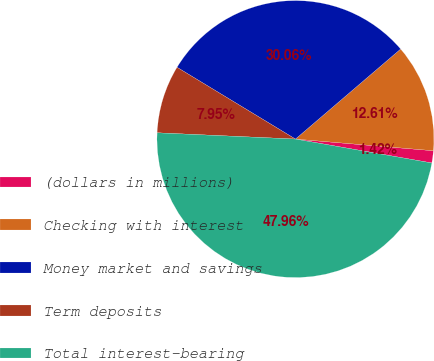Convert chart. <chart><loc_0><loc_0><loc_500><loc_500><pie_chart><fcel>(dollars in millions)<fcel>Checking with interest<fcel>Money market and savings<fcel>Term deposits<fcel>Total interest-bearing<nl><fcel>1.42%<fcel>12.61%<fcel>30.06%<fcel>7.95%<fcel>47.96%<nl></chart> 